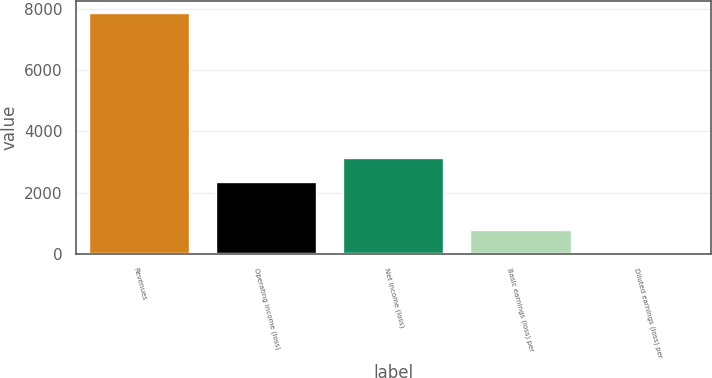Convert chart to OTSL. <chart><loc_0><loc_0><loc_500><loc_500><bar_chart><fcel>Revenues<fcel>Operating income (loss)<fcel>Net income (loss)<fcel>Basic earnings (loss) per<fcel>Diluted earnings (loss) per<nl><fcel>7852<fcel>2356.14<fcel>3141.26<fcel>785.9<fcel>0.78<nl></chart> 